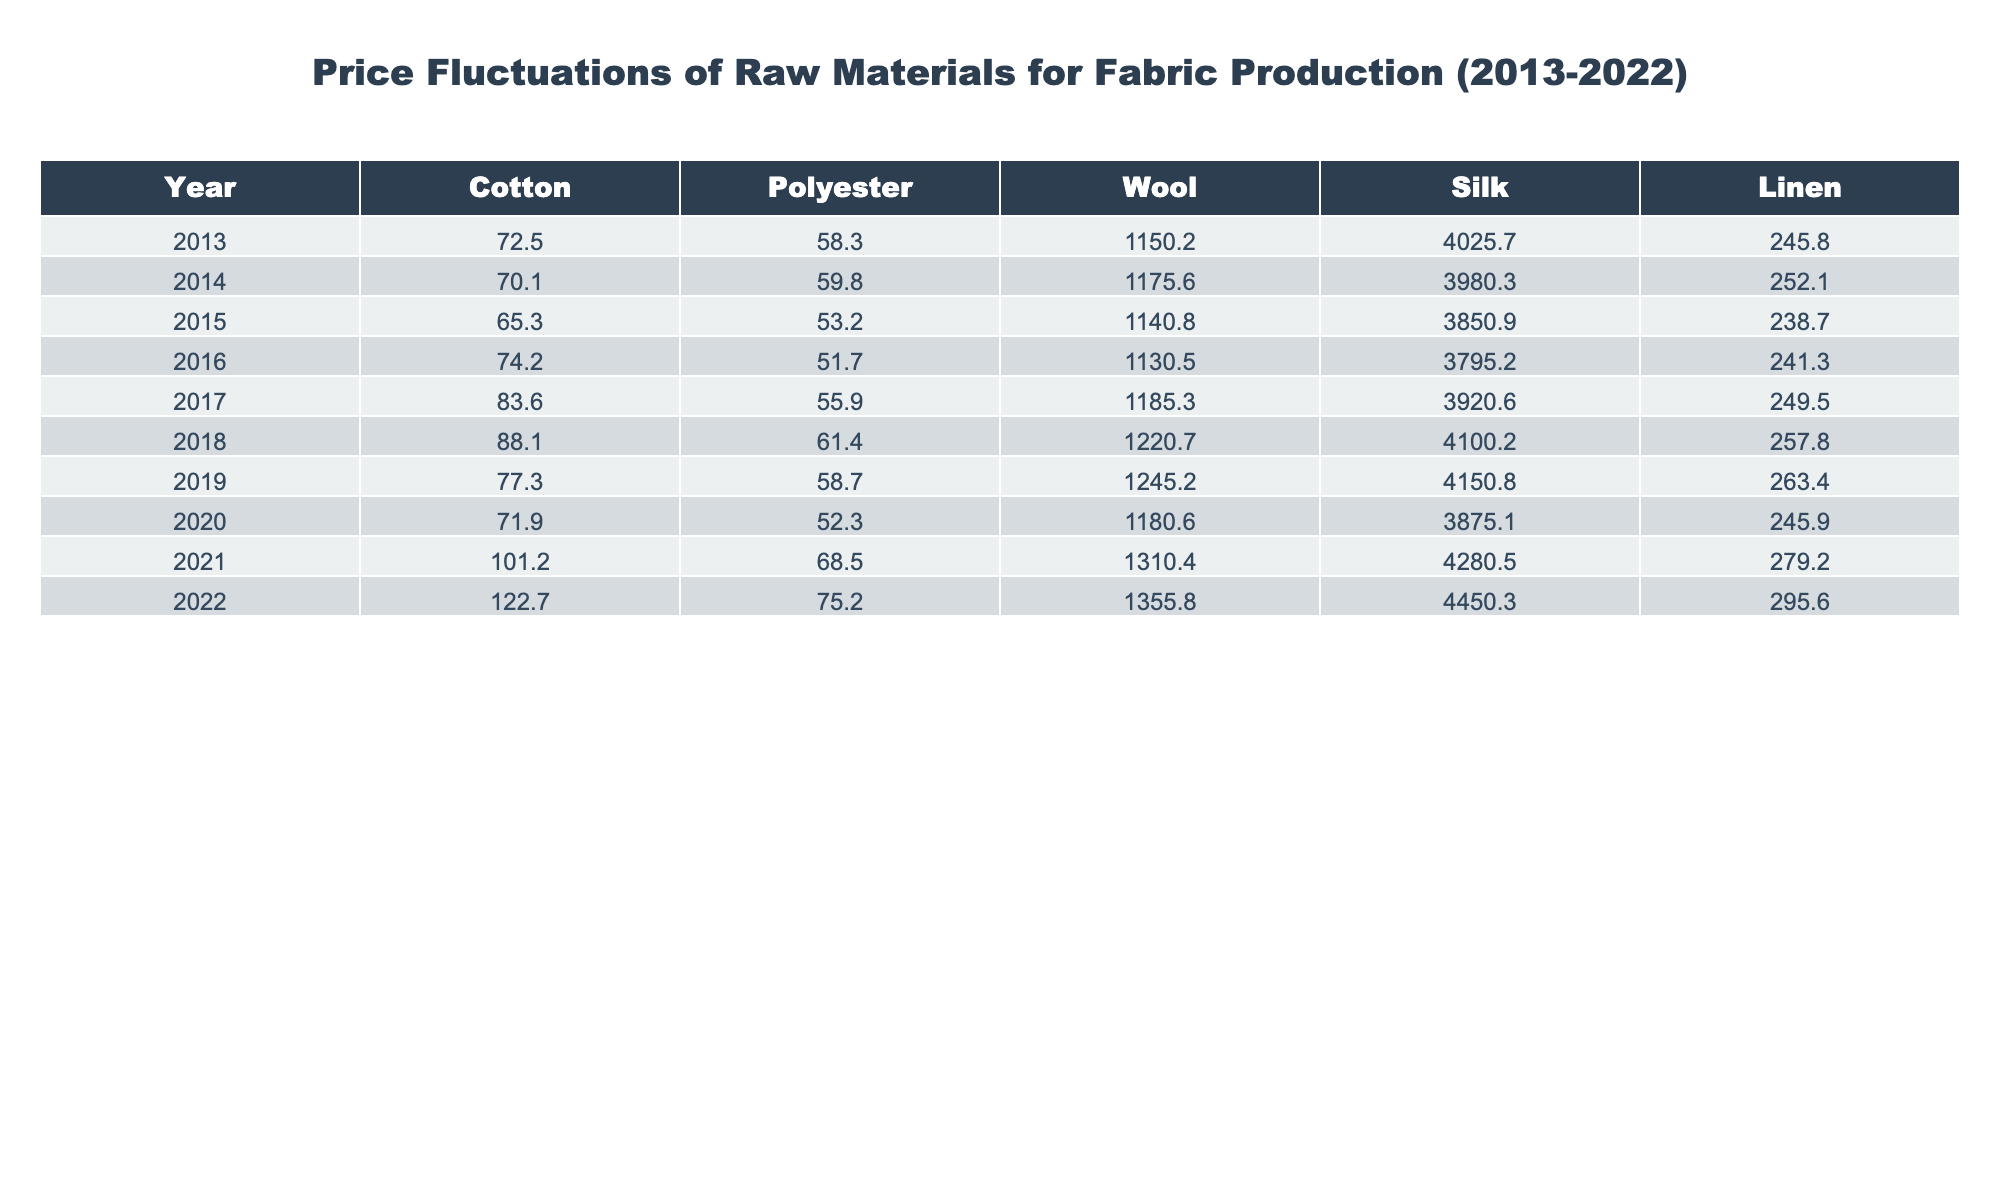What was the price of cotton in 2022? The table shows that the price of cotton is listed under the "Cotton" column for the year 2022. It is recorded as 122.7.
Answer: 122.7 What is the average price of polyester over the last decade? To find the average price of polyester, we add the prices from each year (58.3 + 59.8 + 53.2 + 51.7 + 55.9 + 61.4 + 58.7 + 52.3 + 68.5 + 75.2 =  553.8) and divide by the number of years, which is 10. Thus, the average is 553.8 / 10 = 55.38.
Answer: 55.38 Did the price of silk increase in 2021 compared to 2020? Looking at the prices for silk in the table, it was 3875.1 in 2020 and increased to 4280.5 in 2021. Since 4280.5 is greater than 3875.1, the price did increase.
Answer: Yes Which material had the highest price in 2019? From the table, we can see the prices for each material in 2019: Cotton (77.3), Polyester (58.7), Wool (1245.2), Silk (4150.8), and Linen (263.4). Comparing these, wool at 1245.2 is the highest price listed.
Answer: Wool What was the percentage increase in the price of linen from 2013 to 2022? For linen, the price in 2013 was 245.8 and in 2022 it was 295.6. First, we calculate the increase: 295.6 - 245.8 = 49.8. Then we find the percentage increase: (49.8 / 245.8) * 100 = 20.24%.
Answer: 20.24% Which year experienced the highest price for silk? By examining the price of silk across the years in the table, we can see silk's highest price was in 2022, recorded at 4450.3.
Answer: 2022 What is the difference in the price of wool between 2013 and 2022? The price of wool in 2013 was 1150.2 and in 2022 it was 1355.8. To find the difference, we subtract the earlier price from the later price: 1355.8 - 1150.2 = 205.6.
Answer: 205.6 In which year did polyester see its lowest price? By checking the polyester prices in the table, we see the lowest price is 51.7 in 2016 compared to all other years.
Answer: 2016 What was the overall trend of cotton prices from 2013 to 2022? To determine the trend, we look at the cotton prices: they started at 72.5 in 2013 and went up to 122.7 in 2022. As the price increased throughout the years with some fluctuations, we can conclude that the overall trend is an upwards trend.
Answer: Upwards trend What was the total cost of all raw materials in 2021? To find the total cost for 2021, we need to add the prices for all materials: 101.2 (Cotton) + 68.5 (Polyester) + 1310.4 (Wool) + 4280.5 (Silk) + 279.2 (Linen) = 5759.8.
Answer: 5759.8 